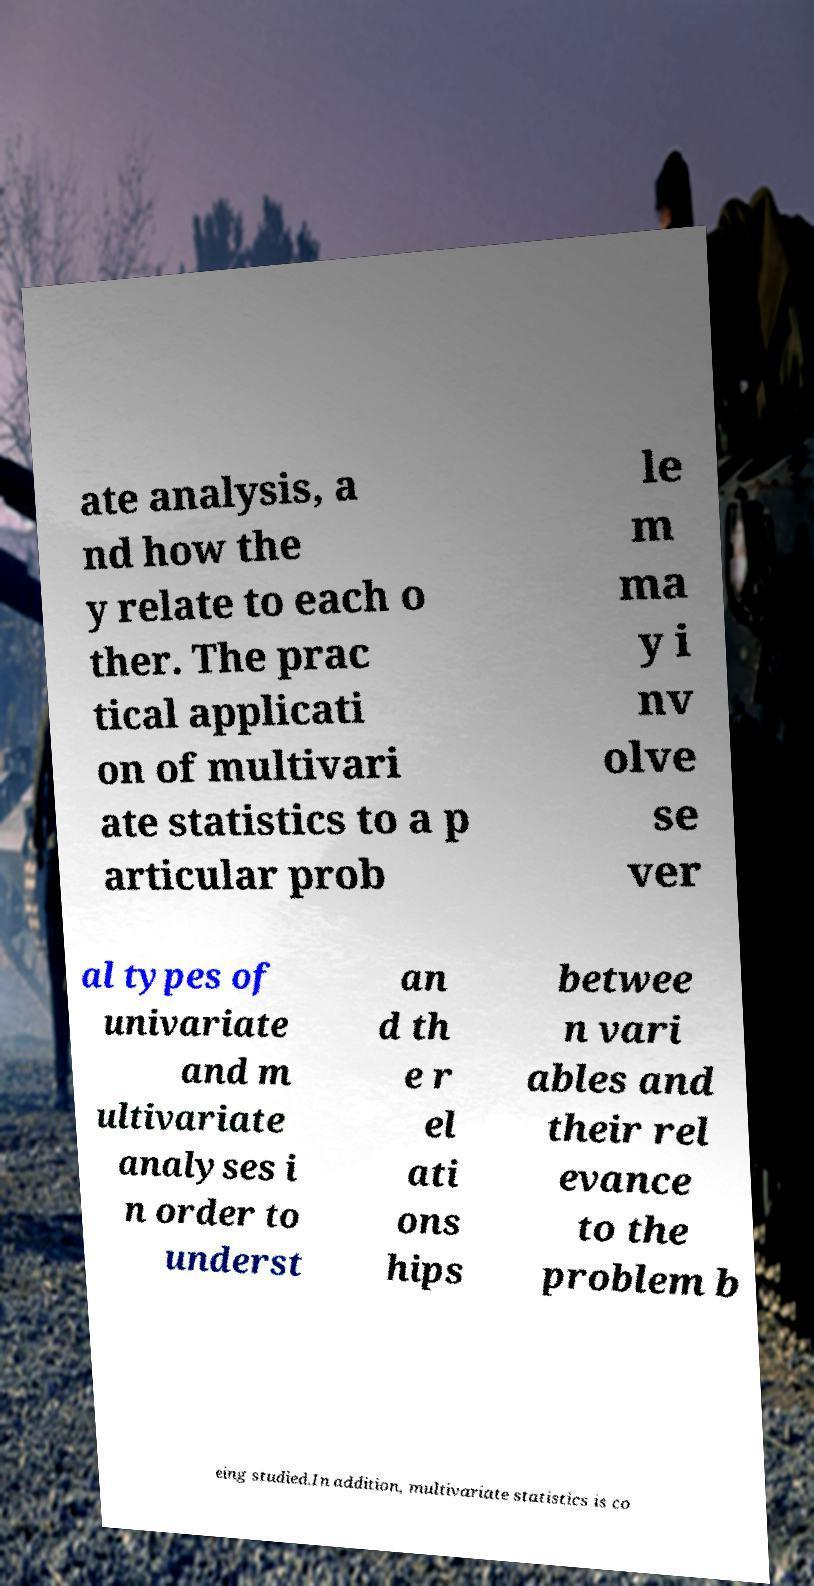Could you assist in decoding the text presented in this image and type it out clearly? ate analysis, a nd how the y relate to each o ther. The prac tical applicati on of multivari ate statistics to a p articular prob le m ma y i nv olve se ver al types of univariate and m ultivariate analyses i n order to underst an d th e r el ati ons hips betwee n vari ables and their rel evance to the problem b eing studied.In addition, multivariate statistics is co 